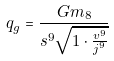<formula> <loc_0><loc_0><loc_500><loc_500>q _ { g } = \frac { G m _ { 8 } } { s ^ { 9 } \sqrt { 1 \cdot \frac { v ^ { 9 } } { j ^ { 9 } } } }</formula> 